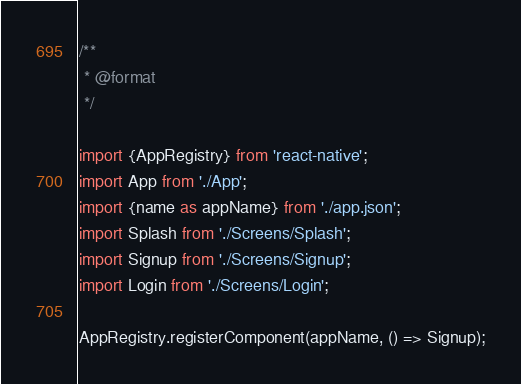Convert code to text. <code><loc_0><loc_0><loc_500><loc_500><_JavaScript_>/**
 * @format
 */

import {AppRegistry} from 'react-native';
import App from './App';
import {name as appName} from './app.json';
import Splash from './Screens/Splash';
import Signup from './Screens/Signup';
import Login from './Screens/Login';

AppRegistry.registerComponent(appName, () => Signup);
</code> 